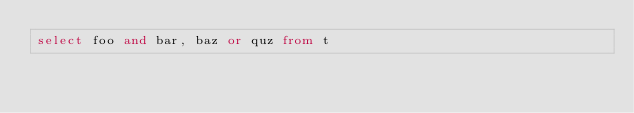Convert code to text. <code><loc_0><loc_0><loc_500><loc_500><_SQL_>select foo and bar, baz or quz from t
</code> 